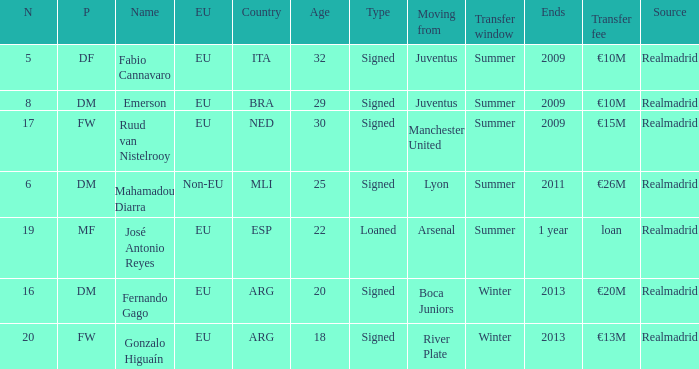What classification does esp hold in the eu? EU. Would you be able to parse every entry in this table? {'header': ['N', 'P', 'Name', 'EU', 'Country', 'Age', 'Type', 'Moving from', 'Transfer window', 'Ends', 'Transfer fee', 'Source'], 'rows': [['5', 'DF', 'Fabio Cannavaro', 'EU', 'ITA', '32', 'Signed', 'Juventus', 'Summer', '2009', '€10M', 'Realmadrid'], ['8', 'DM', 'Emerson', 'EU', 'BRA', '29', 'Signed', 'Juventus', 'Summer', '2009', '€10M', 'Realmadrid'], ['17', 'FW', 'Ruud van Nistelrooy', 'EU', 'NED', '30', 'Signed', 'Manchester United', 'Summer', '2009', '€15M', 'Realmadrid'], ['6', 'DM', 'Mahamadou Diarra', 'Non-EU', 'MLI', '25', 'Signed', 'Lyon', 'Summer', '2011', '€26M', 'Realmadrid'], ['19', 'MF', 'José Antonio Reyes', 'EU', 'ESP', '22', 'Loaned', 'Arsenal', 'Summer', '1 year', 'loan', 'Realmadrid'], ['16', 'DM', 'Fernando Gago', 'EU', 'ARG', '20', 'Signed', 'Boca Juniors', 'Winter', '2013', '€20M', 'Realmadrid'], ['20', 'FW', 'Gonzalo Higuaín', 'EU', 'ARG', '18', 'Signed', 'River Plate', 'Winter', '2013', '€13M', 'Realmadrid']]} 